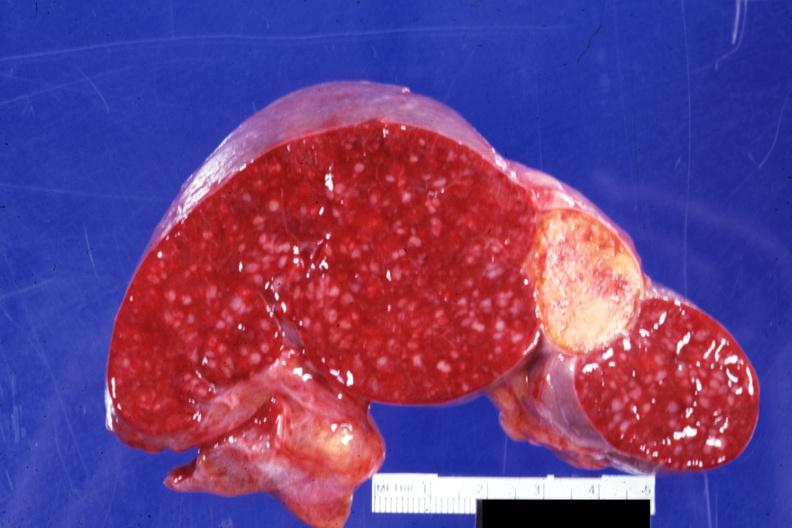what healed infarct quite typical embolus for aortic valve prosthesis?
Answer the question using a single word or phrase. Cut surface with remote and now 